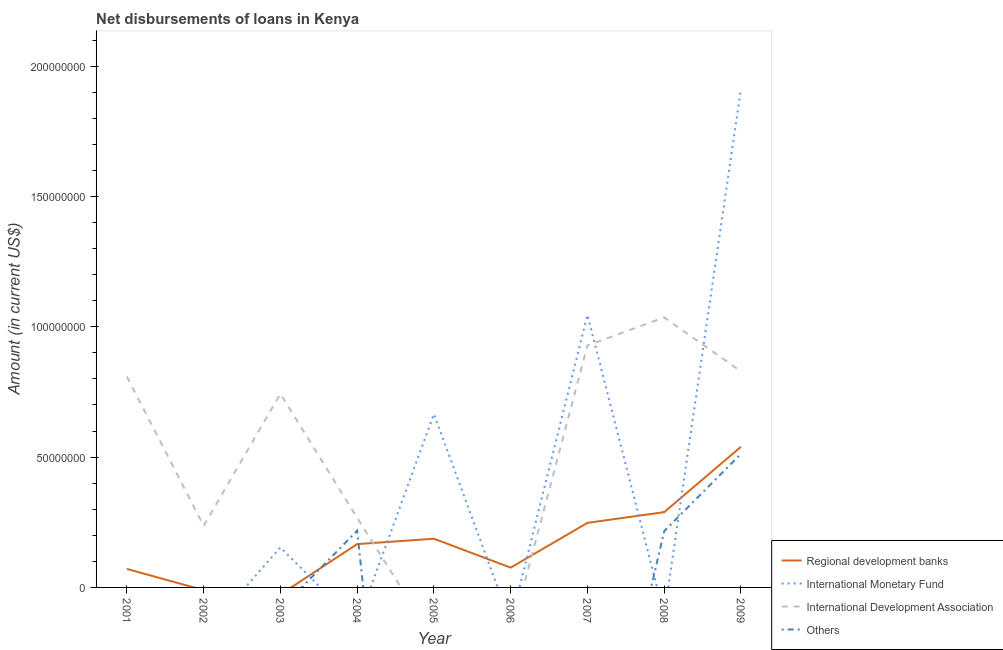Is the number of lines equal to the number of legend labels?
Keep it short and to the point. No. What is the amount of loan disimbursed by international monetary fund in 2009?
Make the answer very short. 1.91e+08. Across all years, what is the maximum amount of loan disimbursed by international development association?
Your answer should be very brief. 1.04e+08. Across all years, what is the minimum amount of loan disimbursed by other organisations?
Offer a very short reply. 0. In which year was the amount of loan disimbursed by international monetary fund maximum?
Provide a short and direct response. 2009. What is the total amount of loan disimbursed by regional development banks in the graph?
Keep it short and to the point. 1.58e+08. What is the difference between the amount of loan disimbursed by international development association in 2001 and that in 2002?
Ensure brevity in your answer.  5.73e+07. What is the difference between the amount of loan disimbursed by regional development banks in 2007 and the amount of loan disimbursed by international development association in 2008?
Provide a short and direct response. -7.88e+07. What is the average amount of loan disimbursed by other organisations per year?
Your answer should be compact. 1.05e+07. In the year 2001, what is the difference between the amount of loan disimbursed by international development association and amount of loan disimbursed by regional development banks?
Make the answer very short. 7.38e+07. In how many years, is the amount of loan disimbursed by international monetary fund greater than 90000000 US$?
Provide a succinct answer. 2. What is the ratio of the amount of loan disimbursed by international development association in 2002 to that in 2003?
Provide a short and direct response. 0.32. Is the difference between the amount of loan disimbursed by international development association in 2001 and 2004 greater than the difference between the amount of loan disimbursed by regional development banks in 2001 and 2004?
Offer a terse response. Yes. What is the difference between the highest and the second highest amount of loan disimbursed by other organisations?
Your response must be concise. 2.95e+07. What is the difference between the highest and the lowest amount of loan disimbursed by other organisations?
Give a very brief answer. 5.12e+07. In how many years, is the amount of loan disimbursed by international monetary fund greater than the average amount of loan disimbursed by international monetary fund taken over all years?
Your response must be concise. 3. Is it the case that in every year, the sum of the amount of loan disimbursed by international development association and amount of loan disimbursed by regional development banks is greater than the sum of amount of loan disimbursed by international monetary fund and amount of loan disimbursed by other organisations?
Your response must be concise. No. Is it the case that in every year, the sum of the amount of loan disimbursed by regional development banks and amount of loan disimbursed by international monetary fund is greater than the amount of loan disimbursed by international development association?
Your answer should be very brief. No. Is the amount of loan disimbursed by international monetary fund strictly less than the amount of loan disimbursed by international development association over the years?
Offer a terse response. No. How many lines are there?
Keep it short and to the point. 4. Where does the legend appear in the graph?
Give a very brief answer. Bottom right. How are the legend labels stacked?
Offer a terse response. Vertical. What is the title of the graph?
Your answer should be very brief. Net disbursements of loans in Kenya. Does "Argument" appear as one of the legend labels in the graph?
Your answer should be very brief. No. What is the label or title of the X-axis?
Ensure brevity in your answer.  Year. What is the label or title of the Y-axis?
Keep it short and to the point. Amount (in current US$). What is the Amount (in current US$) in Regional development banks in 2001?
Provide a succinct answer. 7.09e+06. What is the Amount (in current US$) in International Monetary Fund in 2001?
Your answer should be very brief. 0. What is the Amount (in current US$) of International Development Association in 2001?
Give a very brief answer. 8.09e+07. What is the Amount (in current US$) of Others in 2001?
Your answer should be very brief. 0. What is the Amount (in current US$) of Regional development banks in 2002?
Offer a very short reply. 0. What is the Amount (in current US$) of International Development Association in 2002?
Provide a short and direct response. 2.36e+07. What is the Amount (in current US$) in Regional development banks in 2003?
Offer a terse response. 0. What is the Amount (in current US$) in International Monetary Fund in 2003?
Give a very brief answer. 1.53e+07. What is the Amount (in current US$) in International Development Association in 2003?
Your response must be concise. 7.43e+07. What is the Amount (in current US$) in Others in 2003?
Ensure brevity in your answer.  0. What is the Amount (in current US$) of Regional development banks in 2004?
Provide a succinct answer. 1.66e+07. What is the Amount (in current US$) of International Monetary Fund in 2004?
Make the answer very short. 0. What is the Amount (in current US$) in International Development Association in 2004?
Offer a very short reply. 2.67e+07. What is the Amount (in current US$) of Others in 2004?
Offer a terse response. 2.18e+07. What is the Amount (in current US$) in Regional development banks in 2005?
Keep it short and to the point. 1.87e+07. What is the Amount (in current US$) of International Monetary Fund in 2005?
Keep it short and to the point. 6.65e+07. What is the Amount (in current US$) in International Development Association in 2005?
Provide a succinct answer. 0. What is the Amount (in current US$) of Others in 2005?
Provide a succinct answer. 0. What is the Amount (in current US$) of Regional development banks in 2006?
Your answer should be compact. 7.59e+06. What is the Amount (in current US$) in International Monetary Fund in 2006?
Offer a very short reply. 0. What is the Amount (in current US$) of International Development Association in 2006?
Offer a terse response. 0. What is the Amount (in current US$) of Regional development banks in 2007?
Offer a terse response. 2.48e+07. What is the Amount (in current US$) in International Monetary Fund in 2007?
Make the answer very short. 1.05e+08. What is the Amount (in current US$) of International Development Association in 2007?
Give a very brief answer. 9.28e+07. What is the Amount (in current US$) in Others in 2007?
Ensure brevity in your answer.  0. What is the Amount (in current US$) in Regional development banks in 2008?
Offer a very short reply. 2.89e+07. What is the Amount (in current US$) in International Monetary Fund in 2008?
Offer a very short reply. 0. What is the Amount (in current US$) in International Development Association in 2008?
Give a very brief answer. 1.04e+08. What is the Amount (in current US$) of Others in 2008?
Offer a very short reply. 2.16e+07. What is the Amount (in current US$) in Regional development banks in 2009?
Provide a succinct answer. 5.40e+07. What is the Amount (in current US$) in International Monetary Fund in 2009?
Provide a short and direct response. 1.91e+08. What is the Amount (in current US$) of International Development Association in 2009?
Provide a short and direct response. 8.29e+07. What is the Amount (in current US$) in Others in 2009?
Offer a terse response. 5.12e+07. Across all years, what is the maximum Amount (in current US$) in Regional development banks?
Give a very brief answer. 5.40e+07. Across all years, what is the maximum Amount (in current US$) in International Monetary Fund?
Provide a succinct answer. 1.91e+08. Across all years, what is the maximum Amount (in current US$) of International Development Association?
Your answer should be compact. 1.04e+08. Across all years, what is the maximum Amount (in current US$) of Others?
Your answer should be very brief. 5.12e+07. Across all years, what is the minimum Amount (in current US$) of International Monetary Fund?
Offer a very short reply. 0. Across all years, what is the minimum Amount (in current US$) in International Development Association?
Make the answer very short. 0. What is the total Amount (in current US$) in Regional development banks in the graph?
Provide a short and direct response. 1.58e+08. What is the total Amount (in current US$) of International Monetary Fund in the graph?
Provide a short and direct response. 3.78e+08. What is the total Amount (in current US$) in International Development Association in the graph?
Provide a succinct answer. 4.85e+08. What is the total Amount (in current US$) in Others in the graph?
Provide a short and direct response. 9.46e+07. What is the difference between the Amount (in current US$) in International Development Association in 2001 and that in 2002?
Give a very brief answer. 5.73e+07. What is the difference between the Amount (in current US$) in International Development Association in 2001 and that in 2003?
Your answer should be compact. 6.60e+06. What is the difference between the Amount (in current US$) in Regional development banks in 2001 and that in 2004?
Provide a short and direct response. -9.54e+06. What is the difference between the Amount (in current US$) of International Development Association in 2001 and that in 2004?
Your answer should be compact. 5.42e+07. What is the difference between the Amount (in current US$) of Regional development banks in 2001 and that in 2005?
Make the answer very short. -1.16e+07. What is the difference between the Amount (in current US$) of Regional development banks in 2001 and that in 2006?
Provide a succinct answer. -5.01e+05. What is the difference between the Amount (in current US$) of Regional development banks in 2001 and that in 2007?
Make the answer very short. -1.77e+07. What is the difference between the Amount (in current US$) in International Development Association in 2001 and that in 2007?
Make the answer very short. -1.19e+07. What is the difference between the Amount (in current US$) in Regional development banks in 2001 and that in 2008?
Your answer should be very brief. -2.18e+07. What is the difference between the Amount (in current US$) of International Development Association in 2001 and that in 2008?
Provide a short and direct response. -2.27e+07. What is the difference between the Amount (in current US$) in Regional development banks in 2001 and that in 2009?
Offer a very short reply. -4.69e+07. What is the difference between the Amount (in current US$) of International Development Association in 2001 and that in 2009?
Keep it short and to the point. -1.96e+06. What is the difference between the Amount (in current US$) in International Development Association in 2002 and that in 2003?
Make the answer very short. -5.07e+07. What is the difference between the Amount (in current US$) in International Development Association in 2002 and that in 2004?
Give a very brief answer. -3.06e+06. What is the difference between the Amount (in current US$) in International Development Association in 2002 and that in 2007?
Your response must be concise. -6.92e+07. What is the difference between the Amount (in current US$) in International Development Association in 2002 and that in 2008?
Offer a terse response. -7.99e+07. What is the difference between the Amount (in current US$) of International Development Association in 2002 and that in 2009?
Provide a succinct answer. -5.92e+07. What is the difference between the Amount (in current US$) of International Development Association in 2003 and that in 2004?
Offer a very short reply. 4.76e+07. What is the difference between the Amount (in current US$) of International Monetary Fund in 2003 and that in 2005?
Offer a terse response. -5.12e+07. What is the difference between the Amount (in current US$) in International Monetary Fund in 2003 and that in 2007?
Give a very brief answer. -8.92e+07. What is the difference between the Amount (in current US$) in International Development Association in 2003 and that in 2007?
Offer a terse response. -1.85e+07. What is the difference between the Amount (in current US$) of International Development Association in 2003 and that in 2008?
Offer a terse response. -2.93e+07. What is the difference between the Amount (in current US$) in International Monetary Fund in 2003 and that in 2009?
Keep it short and to the point. -1.76e+08. What is the difference between the Amount (in current US$) of International Development Association in 2003 and that in 2009?
Your answer should be very brief. -8.56e+06. What is the difference between the Amount (in current US$) of Regional development banks in 2004 and that in 2005?
Your answer should be very brief. -2.06e+06. What is the difference between the Amount (in current US$) of Regional development banks in 2004 and that in 2006?
Your answer should be compact. 9.04e+06. What is the difference between the Amount (in current US$) in Regional development banks in 2004 and that in 2007?
Your answer should be compact. -8.14e+06. What is the difference between the Amount (in current US$) of International Development Association in 2004 and that in 2007?
Offer a very short reply. -6.61e+07. What is the difference between the Amount (in current US$) of Regional development banks in 2004 and that in 2008?
Make the answer very short. -1.23e+07. What is the difference between the Amount (in current US$) of International Development Association in 2004 and that in 2008?
Your answer should be compact. -7.69e+07. What is the difference between the Amount (in current US$) of Others in 2004 and that in 2008?
Offer a very short reply. 1.68e+05. What is the difference between the Amount (in current US$) of Regional development banks in 2004 and that in 2009?
Your answer should be very brief. -3.73e+07. What is the difference between the Amount (in current US$) in International Development Association in 2004 and that in 2009?
Offer a very short reply. -5.62e+07. What is the difference between the Amount (in current US$) of Others in 2004 and that in 2009?
Your answer should be compact. -2.95e+07. What is the difference between the Amount (in current US$) of Regional development banks in 2005 and that in 2006?
Keep it short and to the point. 1.11e+07. What is the difference between the Amount (in current US$) of Regional development banks in 2005 and that in 2007?
Offer a terse response. -6.08e+06. What is the difference between the Amount (in current US$) in International Monetary Fund in 2005 and that in 2007?
Your response must be concise. -3.80e+07. What is the difference between the Amount (in current US$) of Regional development banks in 2005 and that in 2008?
Make the answer very short. -1.02e+07. What is the difference between the Amount (in current US$) of Regional development banks in 2005 and that in 2009?
Your answer should be very brief. -3.53e+07. What is the difference between the Amount (in current US$) of International Monetary Fund in 2005 and that in 2009?
Make the answer very short. -1.25e+08. What is the difference between the Amount (in current US$) in Regional development banks in 2006 and that in 2007?
Your answer should be very brief. -1.72e+07. What is the difference between the Amount (in current US$) in Regional development banks in 2006 and that in 2008?
Offer a very short reply. -2.13e+07. What is the difference between the Amount (in current US$) in Regional development banks in 2006 and that in 2009?
Your response must be concise. -4.64e+07. What is the difference between the Amount (in current US$) of Regional development banks in 2007 and that in 2008?
Provide a short and direct response. -4.12e+06. What is the difference between the Amount (in current US$) in International Development Association in 2007 and that in 2008?
Give a very brief answer. -1.08e+07. What is the difference between the Amount (in current US$) of Regional development banks in 2007 and that in 2009?
Offer a very short reply. -2.92e+07. What is the difference between the Amount (in current US$) of International Monetary Fund in 2007 and that in 2009?
Give a very brief answer. -8.67e+07. What is the difference between the Amount (in current US$) of International Development Association in 2007 and that in 2009?
Make the answer very short. 9.95e+06. What is the difference between the Amount (in current US$) of Regional development banks in 2008 and that in 2009?
Provide a short and direct response. -2.51e+07. What is the difference between the Amount (in current US$) in International Development Association in 2008 and that in 2009?
Keep it short and to the point. 2.07e+07. What is the difference between the Amount (in current US$) in Others in 2008 and that in 2009?
Provide a short and direct response. -2.96e+07. What is the difference between the Amount (in current US$) in Regional development banks in 2001 and the Amount (in current US$) in International Development Association in 2002?
Ensure brevity in your answer.  -1.66e+07. What is the difference between the Amount (in current US$) in Regional development banks in 2001 and the Amount (in current US$) in International Monetary Fund in 2003?
Give a very brief answer. -8.25e+06. What is the difference between the Amount (in current US$) of Regional development banks in 2001 and the Amount (in current US$) of International Development Association in 2003?
Ensure brevity in your answer.  -6.72e+07. What is the difference between the Amount (in current US$) in Regional development banks in 2001 and the Amount (in current US$) in International Development Association in 2004?
Your answer should be very brief. -1.96e+07. What is the difference between the Amount (in current US$) in Regional development banks in 2001 and the Amount (in current US$) in Others in 2004?
Your answer should be very brief. -1.47e+07. What is the difference between the Amount (in current US$) of International Development Association in 2001 and the Amount (in current US$) of Others in 2004?
Offer a terse response. 5.91e+07. What is the difference between the Amount (in current US$) of Regional development banks in 2001 and the Amount (in current US$) of International Monetary Fund in 2005?
Keep it short and to the point. -5.94e+07. What is the difference between the Amount (in current US$) of Regional development banks in 2001 and the Amount (in current US$) of International Monetary Fund in 2007?
Offer a terse response. -9.74e+07. What is the difference between the Amount (in current US$) in Regional development banks in 2001 and the Amount (in current US$) in International Development Association in 2007?
Make the answer very short. -8.57e+07. What is the difference between the Amount (in current US$) of Regional development banks in 2001 and the Amount (in current US$) of International Development Association in 2008?
Give a very brief answer. -9.65e+07. What is the difference between the Amount (in current US$) of Regional development banks in 2001 and the Amount (in current US$) of Others in 2008?
Keep it short and to the point. -1.45e+07. What is the difference between the Amount (in current US$) in International Development Association in 2001 and the Amount (in current US$) in Others in 2008?
Your answer should be compact. 5.93e+07. What is the difference between the Amount (in current US$) of Regional development banks in 2001 and the Amount (in current US$) of International Monetary Fund in 2009?
Offer a very short reply. -1.84e+08. What is the difference between the Amount (in current US$) in Regional development banks in 2001 and the Amount (in current US$) in International Development Association in 2009?
Your response must be concise. -7.58e+07. What is the difference between the Amount (in current US$) of Regional development banks in 2001 and the Amount (in current US$) of Others in 2009?
Give a very brief answer. -4.42e+07. What is the difference between the Amount (in current US$) of International Development Association in 2001 and the Amount (in current US$) of Others in 2009?
Ensure brevity in your answer.  2.97e+07. What is the difference between the Amount (in current US$) of International Development Association in 2002 and the Amount (in current US$) of Others in 2004?
Your answer should be compact. 1.88e+06. What is the difference between the Amount (in current US$) of International Development Association in 2002 and the Amount (in current US$) of Others in 2008?
Offer a very short reply. 2.04e+06. What is the difference between the Amount (in current US$) of International Development Association in 2002 and the Amount (in current US$) of Others in 2009?
Offer a terse response. -2.76e+07. What is the difference between the Amount (in current US$) in International Monetary Fund in 2003 and the Amount (in current US$) in International Development Association in 2004?
Keep it short and to the point. -1.14e+07. What is the difference between the Amount (in current US$) of International Monetary Fund in 2003 and the Amount (in current US$) of Others in 2004?
Your response must be concise. -6.42e+06. What is the difference between the Amount (in current US$) in International Development Association in 2003 and the Amount (in current US$) in Others in 2004?
Ensure brevity in your answer.  5.25e+07. What is the difference between the Amount (in current US$) in International Monetary Fund in 2003 and the Amount (in current US$) in International Development Association in 2007?
Keep it short and to the point. -7.75e+07. What is the difference between the Amount (in current US$) of International Monetary Fund in 2003 and the Amount (in current US$) of International Development Association in 2008?
Keep it short and to the point. -8.82e+07. What is the difference between the Amount (in current US$) in International Monetary Fund in 2003 and the Amount (in current US$) in Others in 2008?
Your answer should be very brief. -6.25e+06. What is the difference between the Amount (in current US$) of International Development Association in 2003 and the Amount (in current US$) of Others in 2008?
Keep it short and to the point. 5.27e+07. What is the difference between the Amount (in current US$) of International Monetary Fund in 2003 and the Amount (in current US$) of International Development Association in 2009?
Give a very brief answer. -6.75e+07. What is the difference between the Amount (in current US$) in International Monetary Fund in 2003 and the Amount (in current US$) in Others in 2009?
Offer a terse response. -3.59e+07. What is the difference between the Amount (in current US$) of International Development Association in 2003 and the Amount (in current US$) of Others in 2009?
Make the answer very short. 2.31e+07. What is the difference between the Amount (in current US$) of Regional development banks in 2004 and the Amount (in current US$) of International Monetary Fund in 2005?
Provide a short and direct response. -4.99e+07. What is the difference between the Amount (in current US$) in Regional development banks in 2004 and the Amount (in current US$) in International Monetary Fund in 2007?
Make the answer very short. -8.79e+07. What is the difference between the Amount (in current US$) in Regional development banks in 2004 and the Amount (in current US$) in International Development Association in 2007?
Offer a very short reply. -7.62e+07. What is the difference between the Amount (in current US$) in Regional development banks in 2004 and the Amount (in current US$) in International Development Association in 2008?
Ensure brevity in your answer.  -8.70e+07. What is the difference between the Amount (in current US$) of Regional development banks in 2004 and the Amount (in current US$) of Others in 2008?
Give a very brief answer. -4.97e+06. What is the difference between the Amount (in current US$) of International Development Association in 2004 and the Amount (in current US$) of Others in 2008?
Keep it short and to the point. 5.10e+06. What is the difference between the Amount (in current US$) in Regional development banks in 2004 and the Amount (in current US$) in International Monetary Fund in 2009?
Offer a terse response. -1.75e+08. What is the difference between the Amount (in current US$) of Regional development banks in 2004 and the Amount (in current US$) of International Development Association in 2009?
Your answer should be very brief. -6.62e+07. What is the difference between the Amount (in current US$) in Regional development banks in 2004 and the Amount (in current US$) in Others in 2009?
Give a very brief answer. -3.46e+07. What is the difference between the Amount (in current US$) in International Development Association in 2004 and the Amount (in current US$) in Others in 2009?
Provide a succinct answer. -2.46e+07. What is the difference between the Amount (in current US$) of Regional development banks in 2005 and the Amount (in current US$) of International Monetary Fund in 2007?
Keep it short and to the point. -8.58e+07. What is the difference between the Amount (in current US$) in Regional development banks in 2005 and the Amount (in current US$) in International Development Association in 2007?
Your answer should be very brief. -7.41e+07. What is the difference between the Amount (in current US$) of International Monetary Fund in 2005 and the Amount (in current US$) of International Development Association in 2007?
Give a very brief answer. -2.63e+07. What is the difference between the Amount (in current US$) of Regional development banks in 2005 and the Amount (in current US$) of International Development Association in 2008?
Your response must be concise. -8.49e+07. What is the difference between the Amount (in current US$) in Regional development banks in 2005 and the Amount (in current US$) in Others in 2008?
Ensure brevity in your answer.  -2.91e+06. What is the difference between the Amount (in current US$) in International Monetary Fund in 2005 and the Amount (in current US$) in International Development Association in 2008?
Provide a succinct answer. -3.71e+07. What is the difference between the Amount (in current US$) of International Monetary Fund in 2005 and the Amount (in current US$) of Others in 2008?
Make the answer very short. 4.49e+07. What is the difference between the Amount (in current US$) in Regional development banks in 2005 and the Amount (in current US$) in International Monetary Fund in 2009?
Your answer should be compact. -1.73e+08. What is the difference between the Amount (in current US$) in Regional development banks in 2005 and the Amount (in current US$) in International Development Association in 2009?
Your answer should be compact. -6.42e+07. What is the difference between the Amount (in current US$) in Regional development banks in 2005 and the Amount (in current US$) in Others in 2009?
Make the answer very short. -3.26e+07. What is the difference between the Amount (in current US$) of International Monetary Fund in 2005 and the Amount (in current US$) of International Development Association in 2009?
Make the answer very short. -1.64e+07. What is the difference between the Amount (in current US$) in International Monetary Fund in 2005 and the Amount (in current US$) in Others in 2009?
Your answer should be very brief. 1.53e+07. What is the difference between the Amount (in current US$) of Regional development banks in 2006 and the Amount (in current US$) of International Monetary Fund in 2007?
Your response must be concise. -9.69e+07. What is the difference between the Amount (in current US$) of Regional development banks in 2006 and the Amount (in current US$) of International Development Association in 2007?
Your answer should be very brief. -8.52e+07. What is the difference between the Amount (in current US$) in Regional development banks in 2006 and the Amount (in current US$) in International Development Association in 2008?
Provide a succinct answer. -9.60e+07. What is the difference between the Amount (in current US$) of Regional development banks in 2006 and the Amount (in current US$) of Others in 2008?
Your response must be concise. -1.40e+07. What is the difference between the Amount (in current US$) of Regional development banks in 2006 and the Amount (in current US$) of International Monetary Fund in 2009?
Provide a short and direct response. -1.84e+08. What is the difference between the Amount (in current US$) in Regional development banks in 2006 and the Amount (in current US$) in International Development Association in 2009?
Your answer should be compact. -7.53e+07. What is the difference between the Amount (in current US$) of Regional development banks in 2006 and the Amount (in current US$) of Others in 2009?
Offer a terse response. -4.37e+07. What is the difference between the Amount (in current US$) in Regional development banks in 2007 and the Amount (in current US$) in International Development Association in 2008?
Your answer should be very brief. -7.88e+07. What is the difference between the Amount (in current US$) in Regional development banks in 2007 and the Amount (in current US$) in Others in 2008?
Make the answer very short. 3.17e+06. What is the difference between the Amount (in current US$) in International Monetary Fund in 2007 and the Amount (in current US$) in International Development Association in 2008?
Provide a succinct answer. 9.50e+05. What is the difference between the Amount (in current US$) in International Monetary Fund in 2007 and the Amount (in current US$) in Others in 2008?
Make the answer very short. 8.29e+07. What is the difference between the Amount (in current US$) in International Development Association in 2007 and the Amount (in current US$) in Others in 2008?
Provide a succinct answer. 7.12e+07. What is the difference between the Amount (in current US$) in Regional development banks in 2007 and the Amount (in current US$) in International Monetary Fund in 2009?
Keep it short and to the point. -1.66e+08. What is the difference between the Amount (in current US$) of Regional development banks in 2007 and the Amount (in current US$) of International Development Association in 2009?
Make the answer very short. -5.81e+07. What is the difference between the Amount (in current US$) in Regional development banks in 2007 and the Amount (in current US$) in Others in 2009?
Offer a terse response. -2.65e+07. What is the difference between the Amount (in current US$) of International Monetary Fund in 2007 and the Amount (in current US$) of International Development Association in 2009?
Your response must be concise. 2.17e+07. What is the difference between the Amount (in current US$) of International Monetary Fund in 2007 and the Amount (in current US$) of Others in 2009?
Offer a very short reply. 5.33e+07. What is the difference between the Amount (in current US$) of International Development Association in 2007 and the Amount (in current US$) of Others in 2009?
Your response must be concise. 4.16e+07. What is the difference between the Amount (in current US$) of Regional development banks in 2008 and the Amount (in current US$) of International Monetary Fund in 2009?
Provide a succinct answer. -1.62e+08. What is the difference between the Amount (in current US$) of Regional development banks in 2008 and the Amount (in current US$) of International Development Association in 2009?
Make the answer very short. -5.40e+07. What is the difference between the Amount (in current US$) of Regional development banks in 2008 and the Amount (in current US$) of Others in 2009?
Keep it short and to the point. -2.24e+07. What is the difference between the Amount (in current US$) in International Development Association in 2008 and the Amount (in current US$) in Others in 2009?
Offer a very short reply. 5.23e+07. What is the average Amount (in current US$) in Regional development banks per year?
Your answer should be very brief. 1.75e+07. What is the average Amount (in current US$) of International Monetary Fund per year?
Offer a terse response. 4.20e+07. What is the average Amount (in current US$) of International Development Association per year?
Your response must be concise. 5.39e+07. What is the average Amount (in current US$) of Others per year?
Your answer should be very brief. 1.05e+07. In the year 2001, what is the difference between the Amount (in current US$) of Regional development banks and Amount (in current US$) of International Development Association?
Offer a terse response. -7.38e+07. In the year 2003, what is the difference between the Amount (in current US$) in International Monetary Fund and Amount (in current US$) in International Development Association?
Provide a succinct answer. -5.90e+07. In the year 2004, what is the difference between the Amount (in current US$) of Regional development banks and Amount (in current US$) of International Development Association?
Your response must be concise. -1.01e+07. In the year 2004, what is the difference between the Amount (in current US$) of Regional development banks and Amount (in current US$) of Others?
Give a very brief answer. -5.14e+06. In the year 2004, what is the difference between the Amount (in current US$) of International Development Association and Amount (in current US$) of Others?
Keep it short and to the point. 4.93e+06. In the year 2005, what is the difference between the Amount (in current US$) in Regional development banks and Amount (in current US$) in International Monetary Fund?
Provide a short and direct response. -4.78e+07. In the year 2007, what is the difference between the Amount (in current US$) in Regional development banks and Amount (in current US$) in International Monetary Fund?
Provide a succinct answer. -7.98e+07. In the year 2007, what is the difference between the Amount (in current US$) of Regional development banks and Amount (in current US$) of International Development Association?
Provide a succinct answer. -6.80e+07. In the year 2007, what is the difference between the Amount (in current US$) of International Monetary Fund and Amount (in current US$) of International Development Association?
Provide a succinct answer. 1.17e+07. In the year 2008, what is the difference between the Amount (in current US$) of Regional development banks and Amount (in current US$) of International Development Association?
Provide a succinct answer. -7.47e+07. In the year 2008, what is the difference between the Amount (in current US$) of Regional development banks and Amount (in current US$) of Others?
Offer a terse response. 7.29e+06. In the year 2008, what is the difference between the Amount (in current US$) in International Development Association and Amount (in current US$) in Others?
Make the answer very short. 8.20e+07. In the year 2009, what is the difference between the Amount (in current US$) in Regional development banks and Amount (in current US$) in International Monetary Fund?
Ensure brevity in your answer.  -1.37e+08. In the year 2009, what is the difference between the Amount (in current US$) in Regional development banks and Amount (in current US$) in International Development Association?
Ensure brevity in your answer.  -2.89e+07. In the year 2009, what is the difference between the Amount (in current US$) of Regional development banks and Amount (in current US$) of Others?
Offer a terse response. 2.71e+06. In the year 2009, what is the difference between the Amount (in current US$) of International Monetary Fund and Amount (in current US$) of International Development Association?
Offer a terse response. 1.08e+08. In the year 2009, what is the difference between the Amount (in current US$) of International Monetary Fund and Amount (in current US$) of Others?
Make the answer very short. 1.40e+08. In the year 2009, what is the difference between the Amount (in current US$) in International Development Association and Amount (in current US$) in Others?
Your answer should be compact. 3.16e+07. What is the ratio of the Amount (in current US$) of International Development Association in 2001 to that in 2002?
Keep it short and to the point. 3.42. What is the ratio of the Amount (in current US$) in International Development Association in 2001 to that in 2003?
Ensure brevity in your answer.  1.09. What is the ratio of the Amount (in current US$) in Regional development banks in 2001 to that in 2004?
Offer a very short reply. 0.43. What is the ratio of the Amount (in current US$) in International Development Association in 2001 to that in 2004?
Provide a short and direct response. 3.03. What is the ratio of the Amount (in current US$) in Regional development banks in 2001 to that in 2005?
Make the answer very short. 0.38. What is the ratio of the Amount (in current US$) in Regional development banks in 2001 to that in 2006?
Ensure brevity in your answer.  0.93. What is the ratio of the Amount (in current US$) in Regional development banks in 2001 to that in 2007?
Your answer should be compact. 0.29. What is the ratio of the Amount (in current US$) of International Development Association in 2001 to that in 2007?
Ensure brevity in your answer.  0.87. What is the ratio of the Amount (in current US$) in Regional development banks in 2001 to that in 2008?
Your answer should be compact. 0.25. What is the ratio of the Amount (in current US$) in International Development Association in 2001 to that in 2008?
Your answer should be very brief. 0.78. What is the ratio of the Amount (in current US$) of Regional development banks in 2001 to that in 2009?
Your answer should be compact. 0.13. What is the ratio of the Amount (in current US$) of International Development Association in 2001 to that in 2009?
Your answer should be compact. 0.98. What is the ratio of the Amount (in current US$) in International Development Association in 2002 to that in 2003?
Make the answer very short. 0.32. What is the ratio of the Amount (in current US$) of International Development Association in 2002 to that in 2004?
Provide a succinct answer. 0.89. What is the ratio of the Amount (in current US$) in International Development Association in 2002 to that in 2007?
Ensure brevity in your answer.  0.25. What is the ratio of the Amount (in current US$) in International Development Association in 2002 to that in 2008?
Offer a terse response. 0.23. What is the ratio of the Amount (in current US$) in International Development Association in 2002 to that in 2009?
Provide a succinct answer. 0.29. What is the ratio of the Amount (in current US$) of International Development Association in 2003 to that in 2004?
Keep it short and to the point. 2.78. What is the ratio of the Amount (in current US$) of International Monetary Fund in 2003 to that in 2005?
Keep it short and to the point. 0.23. What is the ratio of the Amount (in current US$) in International Monetary Fund in 2003 to that in 2007?
Offer a terse response. 0.15. What is the ratio of the Amount (in current US$) of International Development Association in 2003 to that in 2007?
Offer a very short reply. 0.8. What is the ratio of the Amount (in current US$) in International Development Association in 2003 to that in 2008?
Make the answer very short. 0.72. What is the ratio of the Amount (in current US$) in International Monetary Fund in 2003 to that in 2009?
Offer a very short reply. 0.08. What is the ratio of the Amount (in current US$) of International Development Association in 2003 to that in 2009?
Make the answer very short. 0.9. What is the ratio of the Amount (in current US$) of Regional development banks in 2004 to that in 2005?
Your answer should be very brief. 0.89. What is the ratio of the Amount (in current US$) in Regional development banks in 2004 to that in 2006?
Offer a terse response. 2.19. What is the ratio of the Amount (in current US$) of Regional development banks in 2004 to that in 2007?
Your response must be concise. 0.67. What is the ratio of the Amount (in current US$) of International Development Association in 2004 to that in 2007?
Make the answer very short. 0.29. What is the ratio of the Amount (in current US$) in Regional development banks in 2004 to that in 2008?
Keep it short and to the point. 0.58. What is the ratio of the Amount (in current US$) of International Development Association in 2004 to that in 2008?
Make the answer very short. 0.26. What is the ratio of the Amount (in current US$) in Regional development banks in 2004 to that in 2009?
Give a very brief answer. 0.31. What is the ratio of the Amount (in current US$) in International Development Association in 2004 to that in 2009?
Keep it short and to the point. 0.32. What is the ratio of the Amount (in current US$) in Others in 2004 to that in 2009?
Keep it short and to the point. 0.42. What is the ratio of the Amount (in current US$) in Regional development banks in 2005 to that in 2006?
Make the answer very short. 2.46. What is the ratio of the Amount (in current US$) of Regional development banks in 2005 to that in 2007?
Offer a terse response. 0.75. What is the ratio of the Amount (in current US$) in International Monetary Fund in 2005 to that in 2007?
Keep it short and to the point. 0.64. What is the ratio of the Amount (in current US$) in Regional development banks in 2005 to that in 2008?
Make the answer very short. 0.65. What is the ratio of the Amount (in current US$) in Regional development banks in 2005 to that in 2009?
Give a very brief answer. 0.35. What is the ratio of the Amount (in current US$) of International Monetary Fund in 2005 to that in 2009?
Ensure brevity in your answer.  0.35. What is the ratio of the Amount (in current US$) of Regional development banks in 2006 to that in 2007?
Provide a short and direct response. 0.31. What is the ratio of the Amount (in current US$) in Regional development banks in 2006 to that in 2008?
Offer a terse response. 0.26. What is the ratio of the Amount (in current US$) in Regional development banks in 2006 to that in 2009?
Offer a very short reply. 0.14. What is the ratio of the Amount (in current US$) of Regional development banks in 2007 to that in 2008?
Your answer should be compact. 0.86. What is the ratio of the Amount (in current US$) in International Development Association in 2007 to that in 2008?
Offer a terse response. 0.9. What is the ratio of the Amount (in current US$) of Regional development banks in 2007 to that in 2009?
Offer a very short reply. 0.46. What is the ratio of the Amount (in current US$) in International Monetary Fund in 2007 to that in 2009?
Provide a succinct answer. 0.55. What is the ratio of the Amount (in current US$) of International Development Association in 2007 to that in 2009?
Provide a succinct answer. 1.12. What is the ratio of the Amount (in current US$) in Regional development banks in 2008 to that in 2009?
Ensure brevity in your answer.  0.54. What is the ratio of the Amount (in current US$) of International Development Association in 2008 to that in 2009?
Your answer should be compact. 1.25. What is the ratio of the Amount (in current US$) of Others in 2008 to that in 2009?
Offer a very short reply. 0.42. What is the difference between the highest and the second highest Amount (in current US$) in Regional development banks?
Keep it short and to the point. 2.51e+07. What is the difference between the highest and the second highest Amount (in current US$) of International Monetary Fund?
Ensure brevity in your answer.  8.67e+07. What is the difference between the highest and the second highest Amount (in current US$) in International Development Association?
Make the answer very short. 1.08e+07. What is the difference between the highest and the second highest Amount (in current US$) of Others?
Make the answer very short. 2.95e+07. What is the difference between the highest and the lowest Amount (in current US$) of Regional development banks?
Your answer should be very brief. 5.40e+07. What is the difference between the highest and the lowest Amount (in current US$) of International Monetary Fund?
Make the answer very short. 1.91e+08. What is the difference between the highest and the lowest Amount (in current US$) in International Development Association?
Make the answer very short. 1.04e+08. What is the difference between the highest and the lowest Amount (in current US$) in Others?
Offer a very short reply. 5.12e+07. 